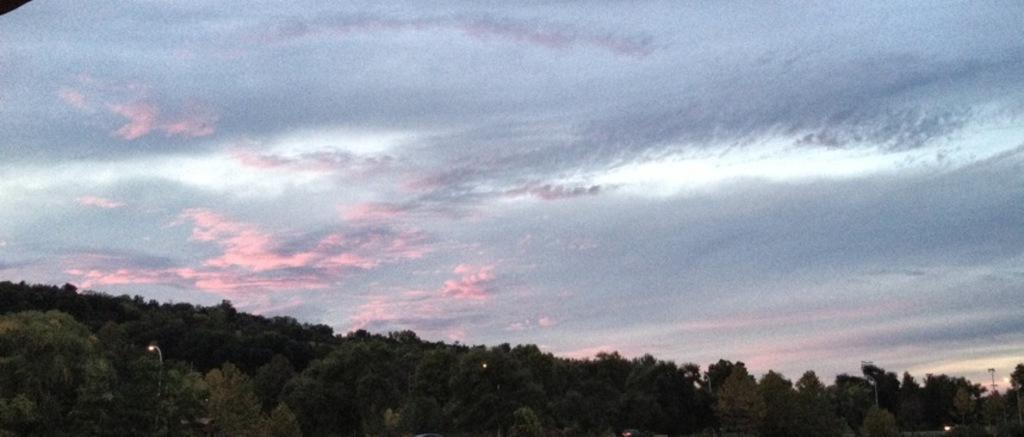How would you summarize this image in a sentence or two? In this image, we can see trees and lights and at the top, there are clouds in the sky. 